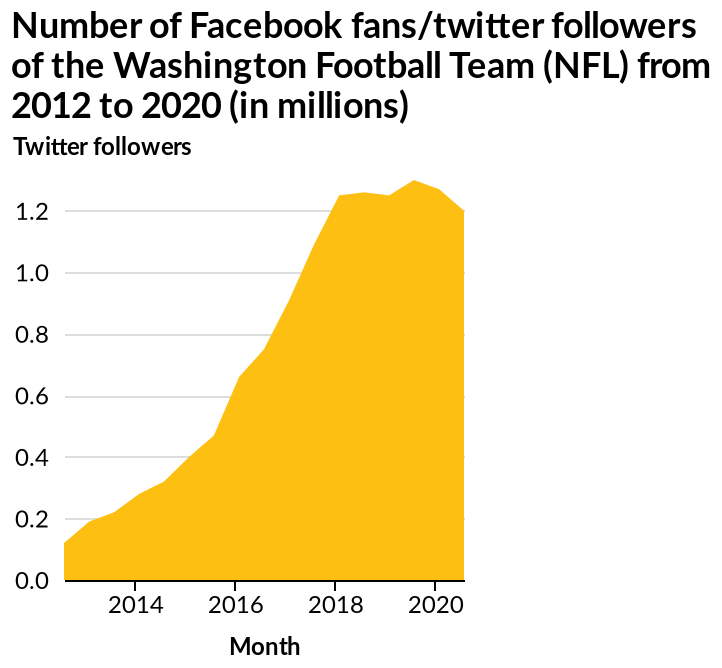<image>
Has there been any change in the number of Facebook/twitter fans for the Washington football team since 2020?  Yes, since 2020 there has been a decrease in the number of Facebook/twitter fans, dropping to 1.20. What is the range of the x-axis scale? The x-axis scale ranges from 2014 to 2020. What is the current number of Facebook/twitter fans for the Washington football team? The current number of Facebook/twitter fans for the Washington football team is 1.20. What is the title of the area chart?  The title of the area chart is "Number of Facebook fans/twitter followers of the Washington Football Team (NFL) from 2012 to 2020 (in millions)." Has there been an increase in the number of Facebook/twitter fans since 2020, rising to 1.20? No. Yes, since 2020 there has been a decrease in the number of Facebook/twitter fans, dropping to 1.20. 